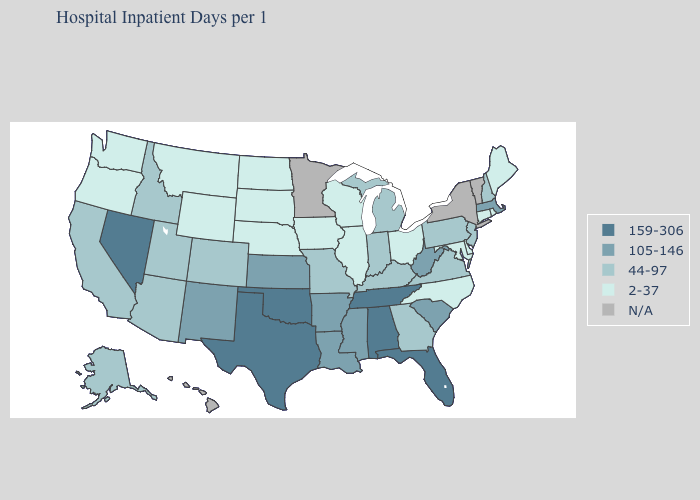Among the states that border Arizona , which have the lowest value?
Write a very short answer. California, Colorado, Utah. Name the states that have a value in the range 105-146?
Give a very brief answer. Arkansas, Kansas, Louisiana, Massachusetts, Mississippi, New Mexico, South Carolina, West Virginia. Name the states that have a value in the range 159-306?
Short answer required. Alabama, Florida, Nevada, Oklahoma, Tennessee, Texas. Among the states that border New Jersey , does Delaware have the highest value?
Keep it brief. No. Which states hav the highest value in the Northeast?
Be succinct. Massachusetts. What is the highest value in states that border Louisiana?
Give a very brief answer. 159-306. Name the states that have a value in the range 159-306?
Keep it brief. Alabama, Florida, Nevada, Oklahoma, Tennessee, Texas. What is the value of Mississippi?
Write a very short answer. 105-146. What is the value of Connecticut?
Answer briefly. 2-37. What is the value of North Dakota?
Write a very short answer. 2-37. What is the value of Oklahoma?
Write a very short answer. 159-306. Does the first symbol in the legend represent the smallest category?
Short answer required. No. What is the value of Wyoming?
Quick response, please. 2-37. 